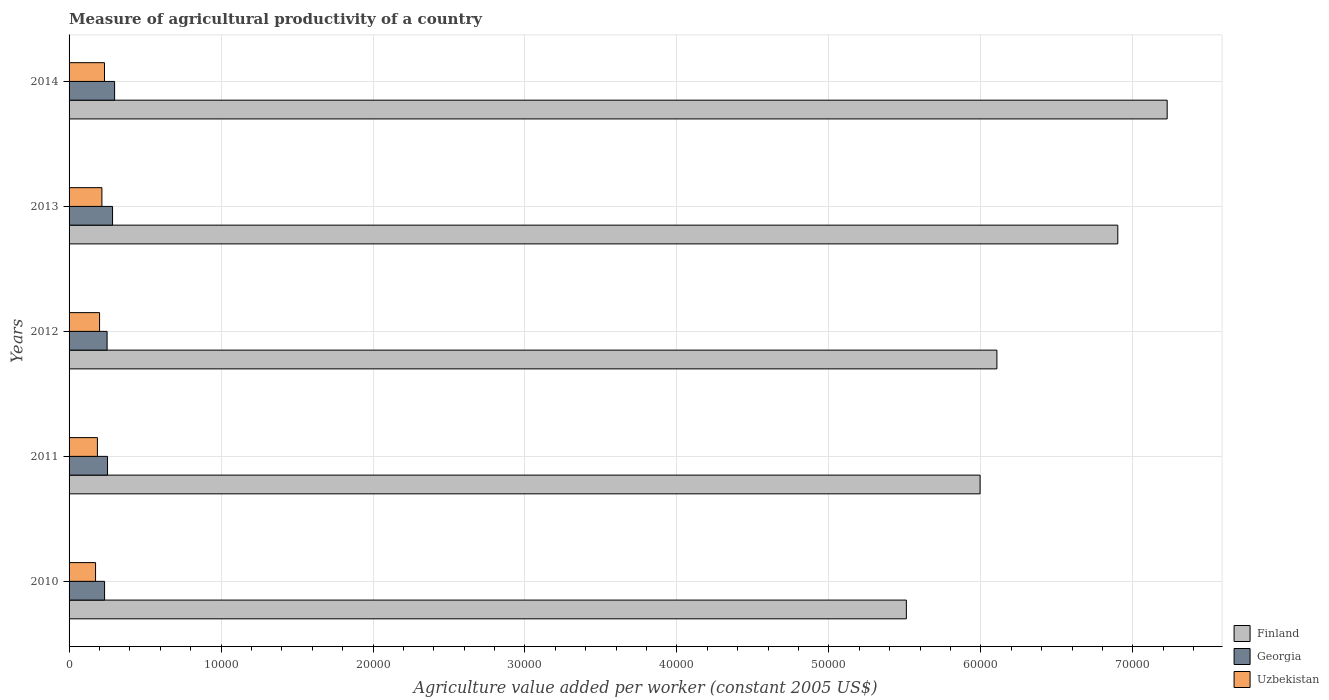Are the number of bars per tick equal to the number of legend labels?
Your answer should be very brief. Yes. Are the number of bars on each tick of the Y-axis equal?
Ensure brevity in your answer.  Yes. How many bars are there on the 2nd tick from the top?
Make the answer very short. 3. In how many cases, is the number of bars for a given year not equal to the number of legend labels?
Keep it short and to the point. 0. What is the measure of agricultural productivity in Georgia in 2013?
Your answer should be compact. 2860.89. Across all years, what is the maximum measure of agricultural productivity in Finland?
Provide a short and direct response. 7.23e+04. Across all years, what is the minimum measure of agricultural productivity in Finland?
Offer a terse response. 5.51e+04. What is the total measure of agricultural productivity in Georgia in the graph?
Your response must be concise. 1.32e+04. What is the difference between the measure of agricultural productivity in Finland in 2011 and that in 2014?
Give a very brief answer. -1.23e+04. What is the difference between the measure of agricultural productivity in Georgia in 2011 and the measure of agricultural productivity in Uzbekistan in 2013?
Provide a short and direct response. 370.37. What is the average measure of agricultural productivity in Finland per year?
Your answer should be compact. 6.35e+04. In the year 2013, what is the difference between the measure of agricultural productivity in Georgia and measure of agricultural productivity in Finland?
Keep it short and to the point. -6.62e+04. In how many years, is the measure of agricultural productivity in Uzbekistan greater than 14000 US$?
Keep it short and to the point. 0. What is the ratio of the measure of agricultural productivity in Finland in 2010 to that in 2012?
Ensure brevity in your answer.  0.9. Is the difference between the measure of agricultural productivity in Georgia in 2012 and 2013 greater than the difference between the measure of agricultural productivity in Finland in 2012 and 2013?
Offer a very short reply. Yes. What is the difference between the highest and the second highest measure of agricultural productivity in Finland?
Keep it short and to the point. 3248.53. What is the difference between the highest and the lowest measure of agricultural productivity in Uzbekistan?
Your answer should be very brief. 588.82. In how many years, is the measure of agricultural productivity in Uzbekistan greater than the average measure of agricultural productivity in Uzbekistan taken over all years?
Your response must be concise. 2. Is the sum of the measure of agricultural productivity in Georgia in 2011 and 2012 greater than the maximum measure of agricultural productivity in Finland across all years?
Ensure brevity in your answer.  No. What does the 1st bar from the top in 2010 represents?
Offer a very short reply. Uzbekistan. What does the 2nd bar from the bottom in 2013 represents?
Offer a terse response. Georgia. Is it the case that in every year, the sum of the measure of agricultural productivity in Uzbekistan and measure of agricultural productivity in Georgia is greater than the measure of agricultural productivity in Finland?
Your response must be concise. No. How many bars are there?
Provide a short and direct response. 15. Are all the bars in the graph horizontal?
Offer a very short reply. Yes. What is the difference between two consecutive major ticks on the X-axis?
Make the answer very short. 10000. Are the values on the major ticks of X-axis written in scientific E-notation?
Provide a succinct answer. No. Does the graph contain any zero values?
Provide a short and direct response. No. Where does the legend appear in the graph?
Provide a short and direct response. Bottom right. How many legend labels are there?
Offer a terse response. 3. How are the legend labels stacked?
Make the answer very short. Vertical. What is the title of the graph?
Your response must be concise. Measure of agricultural productivity of a country. Does "Paraguay" appear as one of the legend labels in the graph?
Your answer should be very brief. No. What is the label or title of the X-axis?
Provide a short and direct response. Agriculture value added per worker (constant 2005 US$). What is the Agriculture value added per worker (constant 2005 US$) in Finland in 2010?
Your answer should be compact. 5.51e+04. What is the Agriculture value added per worker (constant 2005 US$) of Georgia in 2010?
Keep it short and to the point. 2337.06. What is the Agriculture value added per worker (constant 2005 US$) of Uzbekistan in 2010?
Provide a succinct answer. 1742.87. What is the Agriculture value added per worker (constant 2005 US$) of Finland in 2011?
Ensure brevity in your answer.  6.00e+04. What is the Agriculture value added per worker (constant 2005 US$) of Georgia in 2011?
Offer a very short reply. 2531.04. What is the Agriculture value added per worker (constant 2005 US$) in Uzbekistan in 2011?
Offer a very short reply. 1864.79. What is the Agriculture value added per worker (constant 2005 US$) of Finland in 2012?
Your response must be concise. 6.11e+04. What is the Agriculture value added per worker (constant 2005 US$) in Georgia in 2012?
Make the answer very short. 2501.79. What is the Agriculture value added per worker (constant 2005 US$) in Uzbekistan in 2012?
Your answer should be compact. 2007.24. What is the Agriculture value added per worker (constant 2005 US$) of Finland in 2013?
Your response must be concise. 6.90e+04. What is the Agriculture value added per worker (constant 2005 US$) in Georgia in 2013?
Your response must be concise. 2860.89. What is the Agriculture value added per worker (constant 2005 US$) in Uzbekistan in 2013?
Provide a short and direct response. 2160.67. What is the Agriculture value added per worker (constant 2005 US$) in Finland in 2014?
Offer a very short reply. 7.23e+04. What is the Agriculture value added per worker (constant 2005 US$) of Georgia in 2014?
Provide a succinct answer. 2996.7. What is the Agriculture value added per worker (constant 2005 US$) in Uzbekistan in 2014?
Make the answer very short. 2331.69. Across all years, what is the maximum Agriculture value added per worker (constant 2005 US$) of Finland?
Offer a very short reply. 7.23e+04. Across all years, what is the maximum Agriculture value added per worker (constant 2005 US$) of Georgia?
Your response must be concise. 2996.7. Across all years, what is the maximum Agriculture value added per worker (constant 2005 US$) of Uzbekistan?
Give a very brief answer. 2331.69. Across all years, what is the minimum Agriculture value added per worker (constant 2005 US$) of Finland?
Your response must be concise. 5.51e+04. Across all years, what is the minimum Agriculture value added per worker (constant 2005 US$) in Georgia?
Provide a succinct answer. 2337.06. Across all years, what is the minimum Agriculture value added per worker (constant 2005 US$) in Uzbekistan?
Offer a very short reply. 1742.87. What is the total Agriculture value added per worker (constant 2005 US$) of Finland in the graph?
Your answer should be compact. 3.17e+05. What is the total Agriculture value added per worker (constant 2005 US$) of Georgia in the graph?
Offer a terse response. 1.32e+04. What is the total Agriculture value added per worker (constant 2005 US$) in Uzbekistan in the graph?
Ensure brevity in your answer.  1.01e+04. What is the difference between the Agriculture value added per worker (constant 2005 US$) of Finland in 2010 and that in 2011?
Give a very brief answer. -4851.65. What is the difference between the Agriculture value added per worker (constant 2005 US$) of Georgia in 2010 and that in 2011?
Ensure brevity in your answer.  -193.99. What is the difference between the Agriculture value added per worker (constant 2005 US$) in Uzbekistan in 2010 and that in 2011?
Keep it short and to the point. -121.92. What is the difference between the Agriculture value added per worker (constant 2005 US$) of Finland in 2010 and that in 2012?
Offer a very short reply. -5958.46. What is the difference between the Agriculture value added per worker (constant 2005 US$) in Georgia in 2010 and that in 2012?
Your answer should be compact. -164.73. What is the difference between the Agriculture value added per worker (constant 2005 US$) in Uzbekistan in 2010 and that in 2012?
Provide a short and direct response. -264.38. What is the difference between the Agriculture value added per worker (constant 2005 US$) in Finland in 2010 and that in 2013?
Ensure brevity in your answer.  -1.39e+04. What is the difference between the Agriculture value added per worker (constant 2005 US$) of Georgia in 2010 and that in 2013?
Provide a short and direct response. -523.83. What is the difference between the Agriculture value added per worker (constant 2005 US$) in Uzbekistan in 2010 and that in 2013?
Offer a terse response. -417.8. What is the difference between the Agriculture value added per worker (constant 2005 US$) in Finland in 2010 and that in 2014?
Your response must be concise. -1.72e+04. What is the difference between the Agriculture value added per worker (constant 2005 US$) in Georgia in 2010 and that in 2014?
Provide a short and direct response. -659.64. What is the difference between the Agriculture value added per worker (constant 2005 US$) in Uzbekistan in 2010 and that in 2014?
Your answer should be compact. -588.82. What is the difference between the Agriculture value added per worker (constant 2005 US$) of Finland in 2011 and that in 2012?
Keep it short and to the point. -1106.81. What is the difference between the Agriculture value added per worker (constant 2005 US$) of Georgia in 2011 and that in 2012?
Give a very brief answer. 29.25. What is the difference between the Agriculture value added per worker (constant 2005 US$) of Uzbekistan in 2011 and that in 2012?
Offer a very short reply. -142.45. What is the difference between the Agriculture value added per worker (constant 2005 US$) in Finland in 2011 and that in 2013?
Your answer should be compact. -9061.79. What is the difference between the Agriculture value added per worker (constant 2005 US$) of Georgia in 2011 and that in 2013?
Your answer should be very brief. -329.85. What is the difference between the Agriculture value added per worker (constant 2005 US$) of Uzbekistan in 2011 and that in 2013?
Your answer should be very brief. -295.88. What is the difference between the Agriculture value added per worker (constant 2005 US$) of Finland in 2011 and that in 2014?
Ensure brevity in your answer.  -1.23e+04. What is the difference between the Agriculture value added per worker (constant 2005 US$) in Georgia in 2011 and that in 2014?
Your answer should be compact. -465.66. What is the difference between the Agriculture value added per worker (constant 2005 US$) of Uzbekistan in 2011 and that in 2014?
Your answer should be compact. -466.9. What is the difference between the Agriculture value added per worker (constant 2005 US$) in Finland in 2012 and that in 2013?
Ensure brevity in your answer.  -7954.98. What is the difference between the Agriculture value added per worker (constant 2005 US$) in Georgia in 2012 and that in 2013?
Make the answer very short. -359.1. What is the difference between the Agriculture value added per worker (constant 2005 US$) in Uzbekistan in 2012 and that in 2013?
Make the answer very short. -153.43. What is the difference between the Agriculture value added per worker (constant 2005 US$) in Finland in 2012 and that in 2014?
Offer a terse response. -1.12e+04. What is the difference between the Agriculture value added per worker (constant 2005 US$) in Georgia in 2012 and that in 2014?
Offer a very short reply. -494.91. What is the difference between the Agriculture value added per worker (constant 2005 US$) in Uzbekistan in 2012 and that in 2014?
Offer a very short reply. -324.45. What is the difference between the Agriculture value added per worker (constant 2005 US$) in Finland in 2013 and that in 2014?
Provide a succinct answer. -3248.53. What is the difference between the Agriculture value added per worker (constant 2005 US$) of Georgia in 2013 and that in 2014?
Your response must be concise. -135.81. What is the difference between the Agriculture value added per worker (constant 2005 US$) of Uzbekistan in 2013 and that in 2014?
Provide a succinct answer. -171.02. What is the difference between the Agriculture value added per worker (constant 2005 US$) in Finland in 2010 and the Agriculture value added per worker (constant 2005 US$) in Georgia in 2011?
Your answer should be compact. 5.26e+04. What is the difference between the Agriculture value added per worker (constant 2005 US$) in Finland in 2010 and the Agriculture value added per worker (constant 2005 US$) in Uzbekistan in 2011?
Your response must be concise. 5.32e+04. What is the difference between the Agriculture value added per worker (constant 2005 US$) of Georgia in 2010 and the Agriculture value added per worker (constant 2005 US$) of Uzbekistan in 2011?
Your answer should be compact. 472.27. What is the difference between the Agriculture value added per worker (constant 2005 US$) in Finland in 2010 and the Agriculture value added per worker (constant 2005 US$) in Georgia in 2012?
Give a very brief answer. 5.26e+04. What is the difference between the Agriculture value added per worker (constant 2005 US$) in Finland in 2010 and the Agriculture value added per worker (constant 2005 US$) in Uzbekistan in 2012?
Make the answer very short. 5.31e+04. What is the difference between the Agriculture value added per worker (constant 2005 US$) of Georgia in 2010 and the Agriculture value added per worker (constant 2005 US$) of Uzbekistan in 2012?
Make the answer very short. 329.82. What is the difference between the Agriculture value added per worker (constant 2005 US$) in Finland in 2010 and the Agriculture value added per worker (constant 2005 US$) in Georgia in 2013?
Provide a succinct answer. 5.22e+04. What is the difference between the Agriculture value added per worker (constant 2005 US$) of Finland in 2010 and the Agriculture value added per worker (constant 2005 US$) of Uzbekistan in 2013?
Make the answer very short. 5.29e+04. What is the difference between the Agriculture value added per worker (constant 2005 US$) in Georgia in 2010 and the Agriculture value added per worker (constant 2005 US$) in Uzbekistan in 2013?
Make the answer very short. 176.39. What is the difference between the Agriculture value added per worker (constant 2005 US$) in Finland in 2010 and the Agriculture value added per worker (constant 2005 US$) in Georgia in 2014?
Provide a short and direct response. 5.21e+04. What is the difference between the Agriculture value added per worker (constant 2005 US$) in Finland in 2010 and the Agriculture value added per worker (constant 2005 US$) in Uzbekistan in 2014?
Provide a succinct answer. 5.28e+04. What is the difference between the Agriculture value added per worker (constant 2005 US$) of Georgia in 2010 and the Agriculture value added per worker (constant 2005 US$) of Uzbekistan in 2014?
Give a very brief answer. 5.37. What is the difference between the Agriculture value added per worker (constant 2005 US$) of Finland in 2011 and the Agriculture value added per worker (constant 2005 US$) of Georgia in 2012?
Your answer should be compact. 5.74e+04. What is the difference between the Agriculture value added per worker (constant 2005 US$) of Finland in 2011 and the Agriculture value added per worker (constant 2005 US$) of Uzbekistan in 2012?
Provide a short and direct response. 5.79e+04. What is the difference between the Agriculture value added per worker (constant 2005 US$) of Georgia in 2011 and the Agriculture value added per worker (constant 2005 US$) of Uzbekistan in 2012?
Ensure brevity in your answer.  523.8. What is the difference between the Agriculture value added per worker (constant 2005 US$) of Finland in 2011 and the Agriculture value added per worker (constant 2005 US$) of Georgia in 2013?
Provide a succinct answer. 5.71e+04. What is the difference between the Agriculture value added per worker (constant 2005 US$) of Finland in 2011 and the Agriculture value added per worker (constant 2005 US$) of Uzbekistan in 2013?
Provide a short and direct response. 5.78e+04. What is the difference between the Agriculture value added per worker (constant 2005 US$) of Georgia in 2011 and the Agriculture value added per worker (constant 2005 US$) of Uzbekistan in 2013?
Give a very brief answer. 370.37. What is the difference between the Agriculture value added per worker (constant 2005 US$) in Finland in 2011 and the Agriculture value added per worker (constant 2005 US$) in Georgia in 2014?
Provide a succinct answer. 5.70e+04. What is the difference between the Agriculture value added per worker (constant 2005 US$) of Finland in 2011 and the Agriculture value added per worker (constant 2005 US$) of Uzbekistan in 2014?
Provide a short and direct response. 5.76e+04. What is the difference between the Agriculture value added per worker (constant 2005 US$) of Georgia in 2011 and the Agriculture value added per worker (constant 2005 US$) of Uzbekistan in 2014?
Ensure brevity in your answer.  199.35. What is the difference between the Agriculture value added per worker (constant 2005 US$) in Finland in 2012 and the Agriculture value added per worker (constant 2005 US$) in Georgia in 2013?
Provide a short and direct response. 5.82e+04. What is the difference between the Agriculture value added per worker (constant 2005 US$) of Finland in 2012 and the Agriculture value added per worker (constant 2005 US$) of Uzbekistan in 2013?
Offer a very short reply. 5.89e+04. What is the difference between the Agriculture value added per worker (constant 2005 US$) of Georgia in 2012 and the Agriculture value added per worker (constant 2005 US$) of Uzbekistan in 2013?
Provide a short and direct response. 341.12. What is the difference between the Agriculture value added per worker (constant 2005 US$) of Finland in 2012 and the Agriculture value added per worker (constant 2005 US$) of Georgia in 2014?
Provide a short and direct response. 5.81e+04. What is the difference between the Agriculture value added per worker (constant 2005 US$) in Finland in 2012 and the Agriculture value added per worker (constant 2005 US$) in Uzbekistan in 2014?
Provide a short and direct response. 5.87e+04. What is the difference between the Agriculture value added per worker (constant 2005 US$) in Georgia in 2012 and the Agriculture value added per worker (constant 2005 US$) in Uzbekistan in 2014?
Provide a short and direct response. 170.1. What is the difference between the Agriculture value added per worker (constant 2005 US$) of Finland in 2013 and the Agriculture value added per worker (constant 2005 US$) of Georgia in 2014?
Ensure brevity in your answer.  6.60e+04. What is the difference between the Agriculture value added per worker (constant 2005 US$) in Finland in 2013 and the Agriculture value added per worker (constant 2005 US$) in Uzbekistan in 2014?
Your response must be concise. 6.67e+04. What is the difference between the Agriculture value added per worker (constant 2005 US$) in Georgia in 2013 and the Agriculture value added per worker (constant 2005 US$) in Uzbekistan in 2014?
Provide a short and direct response. 529.2. What is the average Agriculture value added per worker (constant 2005 US$) in Finland per year?
Give a very brief answer. 6.35e+04. What is the average Agriculture value added per worker (constant 2005 US$) of Georgia per year?
Keep it short and to the point. 2645.49. What is the average Agriculture value added per worker (constant 2005 US$) of Uzbekistan per year?
Provide a short and direct response. 2021.45. In the year 2010, what is the difference between the Agriculture value added per worker (constant 2005 US$) of Finland and Agriculture value added per worker (constant 2005 US$) of Georgia?
Your response must be concise. 5.28e+04. In the year 2010, what is the difference between the Agriculture value added per worker (constant 2005 US$) in Finland and Agriculture value added per worker (constant 2005 US$) in Uzbekistan?
Provide a short and direct response. 5.34e+04. In the year 2010, what is the difference between the Agriculture value added per worker (constant 2005 US$) of Georgia and Agriculture value added per worker (constant 2005 US$) of Uzbekistan?
Offer a terse response. 594.19. In the year 2011, what is the difference between the Agriculture value added per worker (constant 2005 US$) of Finland and Agriculture value added per worker (constant 2005 US$) of Georgia?
Offer a terse response. 5.74e+04. In the year 2011, what is the difference between the Agriculture value added per worker (constant 2005 US$) in Finland and Agriculture value added per worker (constant 2005 US$) in Uzbekistan?
Your answer should be compact. 5.81e+04. In the year 2011, what is the difference between the Agriculture value added per worker (constant 2005 US$) in Georgia and Agriculture value added per worker (constant 2005 US$) in Uzbekistan?
Provide a succinct answer. 666.25. In the year 2012, what is the difference between the Agriculture value added per worker (constant 2005 US$) of Finland and Agriculture value added per worker (constant 2005 US$) of Georgia?
Ensure brevity in your answer.  5.86e+04. In the year 2012, what is the difference between the Agriculture value added per worker (constant 2005 US$) of Finland and Agriculture value added per worker (constant 2005 US$) of Uzbekistan?
Make the answer very short. 5.90e+04. In the year 2012, what is the difference between the Agriculture value added per worker (constant 2005 US$) in Georgia and Agriculture value added per worker (constant 2005 US$) in Uzbekistan?
Offer a terse response. 494.55. In the year 2013, what is the difference between the Agriculture value added per worker (constant 2005 US$) in Finland and Agriculture value added per worker (constant 2005 US$) in Georgia?
Provide a succinct answer. 6.62e+04. In the year 2013, what is the difference between the Agriculture value added per worker (constant 2005 US$) of Finland and Agriculture value added per worker (constant 2005 US$) of Uzbekistan?
Give a very brief answer. 6.69e+04. In the year 2013, what is the difference between the Agriculture value added per worker (constant 2005 US$) in Georgia and Agriculture value added per worker (constant 2005 US$) in Uzbekistan?
Offer a terse response. 700.22. In the year 2014, what is the difference between the Agriculture value added per worker (constant 2005 US$) in Finland and Agriculture value added per worker (constant 2005 US$) in Georgia?
Offer a terse response. 6.93e+04. In the year 2014, what is the difference between the Agriculture value added per worker (constant 2005 US$) in Finland and Agriculture value added per worker (constant 2005 US$) in Uzbekistan?
Provide a short and direct response. 6.99e+04. In the year 2014, what is the difference between the Agriculture value added per worker (constant 2005 US$) in Georgia and Agriculture value added per worker (constant 2005 US$) in Uzbekistan?
Your answer should be very brief. 665.01. What is the ratio of the Agriculture value added per worker (constant 2005 US$) in Finland in 2010 to that in 2011?
Offer a terse response. 0.92. What is the ratio of the Agriculture value added per worker (constant 2005 US$) of Georgia in 2010 to that in 2011?
Offer a very short reply. 0.92. What is the ratio of the Agriculture value added per worker (constant 2005 US$) in Uzbekistan in 2010 to that in 2011?
Give a very brief answer. 0.93. What is the ratio of the Agriculture value added per worker (constant 2005 US$) in Finland in 2010 to that in 2012?
Keep it short and to the point. 0.9. What is the ratio of the Agriculture value added per worker (constant 2005 US$) in Georgia in 2010 to that in 2012?
Ensure brevity in your answer.  0.93. What is the ratio of the Agriculture value added per worker (constant 2005 US$) in Uzbekistan in 2010 to that in 2012?
Offer a terse response. 0.87. What is the ratio of the Agriculture value added per worker (constant 2005 US$) of Finland in 2010 to that in 2013?
Provide a succinct answer. 0.8. What is the ratio of the Agriculture value added per worker (constant 2005 US$) of Georgia in 2010 to that in 2013?
Provide a short and direct response. 0.82. What is the ratio of the Agriculture value added per worker (constant 2005 US$) of Uzbekistan in 2010 to that in 2013?
Make the answer very short. 0.81. What is the ratio of the Agriculture value added per worker (constant 2005 US$) in Finland in 2010 to that in 2014?
Offer a terse response. 0.76. What is the ratio of the Agriculture value added per worker (constant 2005 US$) of Georgia in 2010 to that in 2014?
Provide a short and direct response. 0.78. What is the ratio of the Agriculture value added per worker (constant 2005 US$) of Uzbekistan in 2010 to that in 2014?
Offer a very short reply. 0.75. What is the ratio of the Agriculture value added per worker (constant 2005 US$) in Finland in 2011 to that in 2012?
Keep it short and to the point. 0.98. What is the ratio of the Agriculture value added per worker (constant 2005 US$) in Georgia in 2011 to that in 2012?
Your answer should be compact. 1.01. What is the ratio of the Agriculture value added per worker (constant 2005 US$) in Uzbekistan in 2011 to that in 2012?
Keep it short and to the point. 0.93. What is the ratio of the Agriculture value added per worker (constant 2005 US$) in Finland in 2011 to that in 2013?
Your answer should be very brief. 0.87. What is the ratio of the Agriculture value added per worker (constant 2005 US$) of Georgia in 2011 to that in 2013?
Offer a very short reply. 0.88. What is the ratio of the Agriculture value added per worker (constant 2005 US$) in Uzbekistan in 2011 to that in 2013?
Offer a very short reply. 0.86. What is the ratio of the Agriculture value added per worker (constant 2005 US$) in Finland in 2011 to that in 2014?
Ensure brevity in your answer.  0.83. What is the ratio of the Agriculture value added per worker (constant 2005 US$) in Georgia in 2011 to that in 2014?
Provide a succinct answer. 0.84. What is the ratio of the Agriculture value added per worker (constant 2005 US$) in Uzbekistan in 2011 to that in 2014?
Offer a very short reply. 0.8. What is the ratio of the Agriculture value added per worker (constant 2005 US$) in Finland in 2012 to that in 2013?
Offer a terse response. 0.88. What is the ratio of the Agriculture value added per worker (constant 2005 US$) in Georgia in 2012 to that in 2013?
Offer a terse response. 0.87. What is the ratio of the Agriculture value added per worker (constant 2005 US$) of Uzbekistan in 2012 to that in 2013?
Your answer should be compact. 0.93. What is the ratio of the Agriculture value added per worker (constant 2005 US$) of Finland in 2012 to that in 2014?
Your answer should be compact. 0.84. What is the ratio of the Agriculture value added per worker (constant 2005 US$) in Georgia in 2012 to that in 2014?
Your answer should be compact. 0.83. What is the ratio of the Agriculture value added per worker (constant 2005 US$) in Uzbekistan in 2012 to that in 2014?
Provide a succinct answer. 0.86. What is the ratio of the Agriculture value added per worker (constant 2005 US$) in Finland in 2013 to that in 2014?
Your answer should be very brief. 0.95. What is the ratio of the Agriculture value added per worker (constant 2005 US$) of Georgia in 2013 to that in 2014?
Provide a short and direct response. 0.95. What is the ratio of the Agriculture value added per worker (constant 2005 US$) in Uzbekistan in 2013 to that in 2014?
Give a very brief answer. 0.93. What is the difference between the highest and the second highest Agriculture value added per worker (constant 2005 US$) in Finland?
Ensure brevity in your answer.  3248.53. What is the difference between the highest and the second highest Agriculture value added per worker (constant 2005 US$) in Georgia?
Offer a terse response. 135.81. What is the difference between the highest and the second highest Agriculture value added per worker (constant 2005 US$) in Uzbekistan?
Offer a very short reply. 171.02. What is the difference between the highest and the lowest Agriculture value added per worker (constant 2005 US$) of Finland?
Your answer should be very brief. 1.72e+04. What is the difference between the highest and the lowest Agriculture value added per worker (constant 2005 US$) in Georgia?
Your answer should be very brief. 659.64. What is the difference between the highest and the lowest Agriculture value added per worker (constant 2005 US$) of Uzbekistan?
Ensure brevity in your answer.  588.82. 